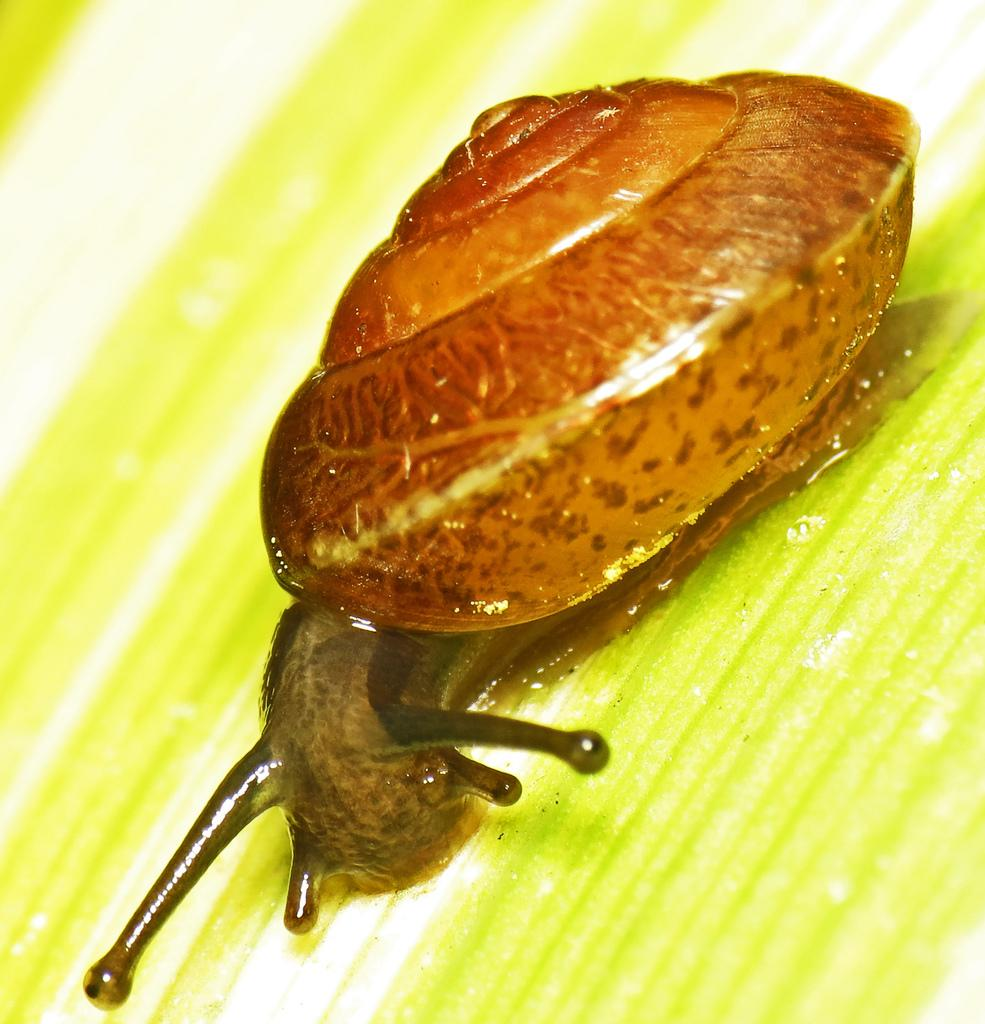What type of animal is in the image? There is a snail in the image. Where is the snail located? The snail is present on a plant. What toys does the girl have in the image? There is no girl or toys present in the image; it only features a snail on a plant. 